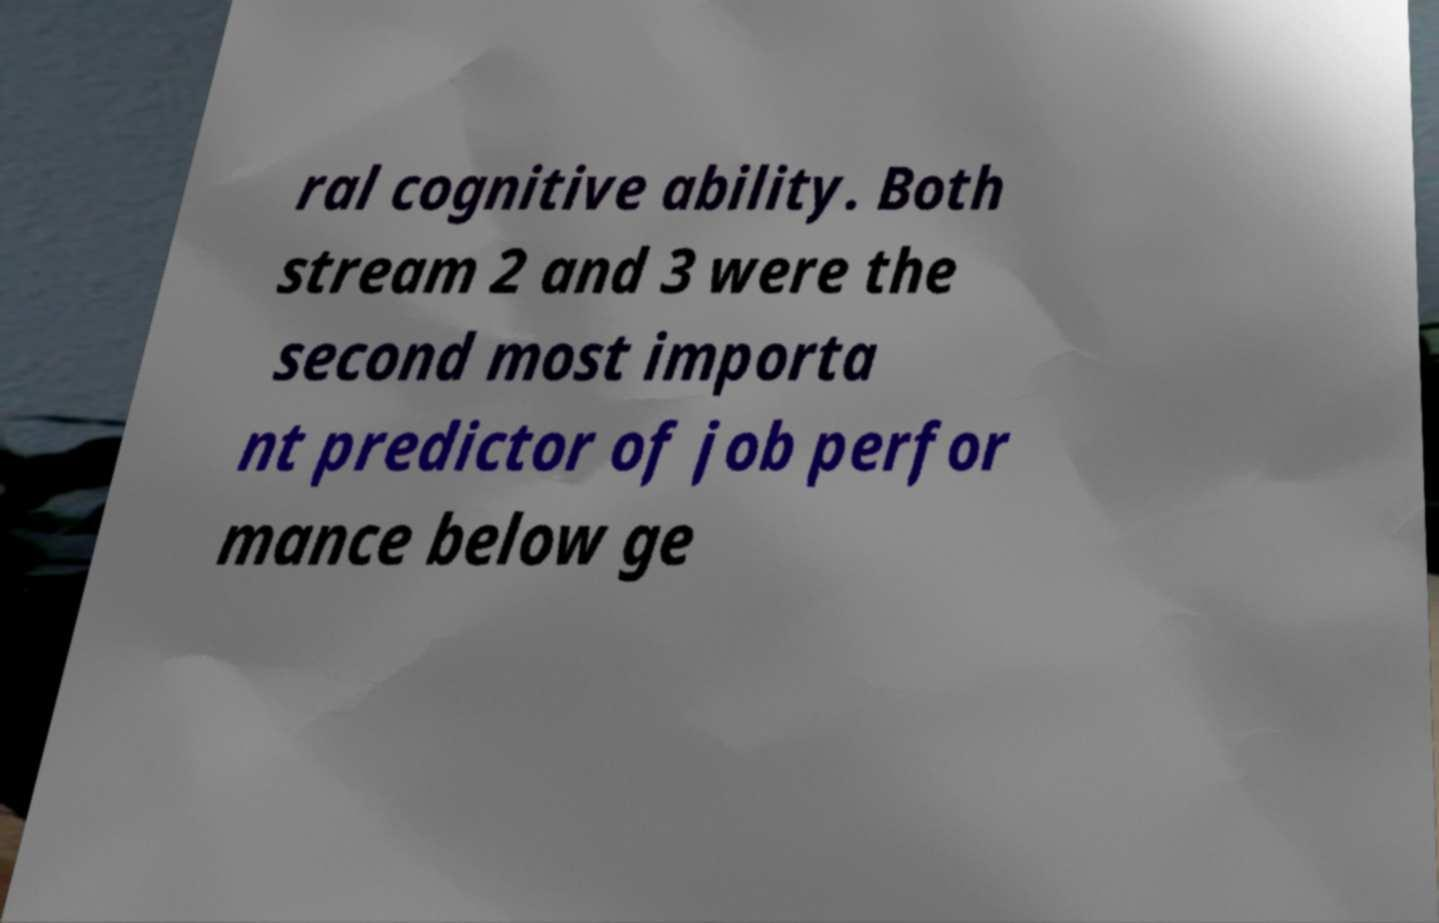Could you assist in decoding the text presented in this image and type it out clearly? ral cognitive ability. Both stream 2 and 3 were the second most importa nt predictor of job perfor mance below ge 